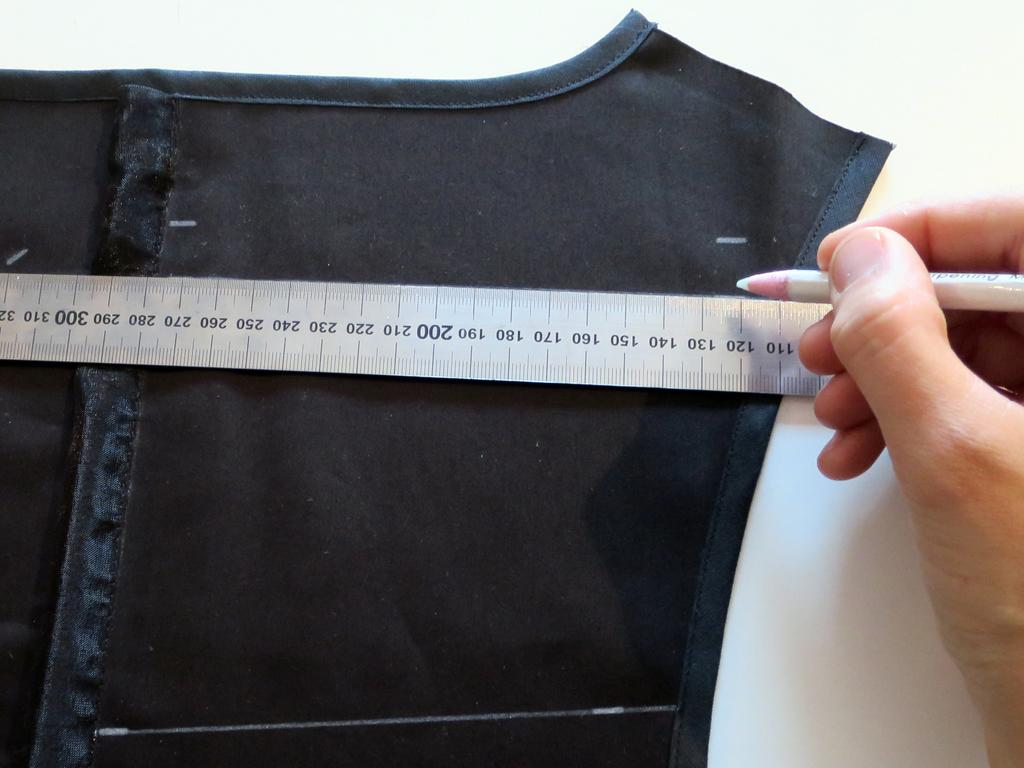What object is present in the image that is used for measuring weight? There is a scale in the image. Who is present in the image? There is a person in the image. What is the person holding in the image? The person is holding a white color pencil. What is the person doing with the pencil in the image? The person is marking on a cloth. How is the steam being distributed in the image? There is no steam present in the image. What is the amount of pencils the person is holding in the image? The person is holding only one pencil in the image. 